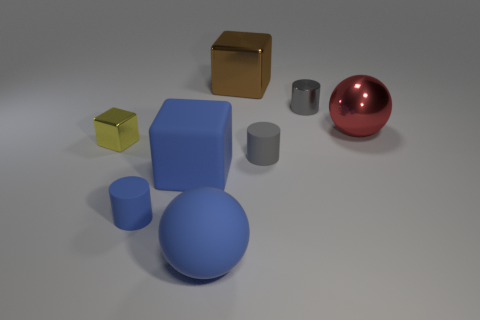There is a object that is both on the left side of the large rubber cube and in front of the yellow block; what is its material?
Make the answer very short. Rubber. There is a small thing behind the red metallic sphere; is it the same shape as the brown metallic object?
Provide a succinct answer. No. Is the number of tiny blue rubber objects less than the number of small gray objects?
Provide a succinct answer. Yes. What number of tiny shiny cylinders have the same color as the large rubber ball?
Make the answer very short. 0. There is a cylinder that is the same color as the rubber ball; what is it made of?
Offer a terse response. Rubber. There is a big matte sphere; is it the same color as the tiny cylinder that is left of the big blue block?
Your response must be concise. Yes. Are there more yellow shiny things than red cylinders?
Ensure brevity in your answer.  Yes. There is a blue rubber object that is the same shape as the brown object; what is its size?
Your response must be concise. Large. Are the big red sphere and the sphere in front of the yellow metal thing made of the same material?
Give a very brief answer. No. What number of objects are either brown metallic objects or large blue cubes?
Make the answer very short. 2. 